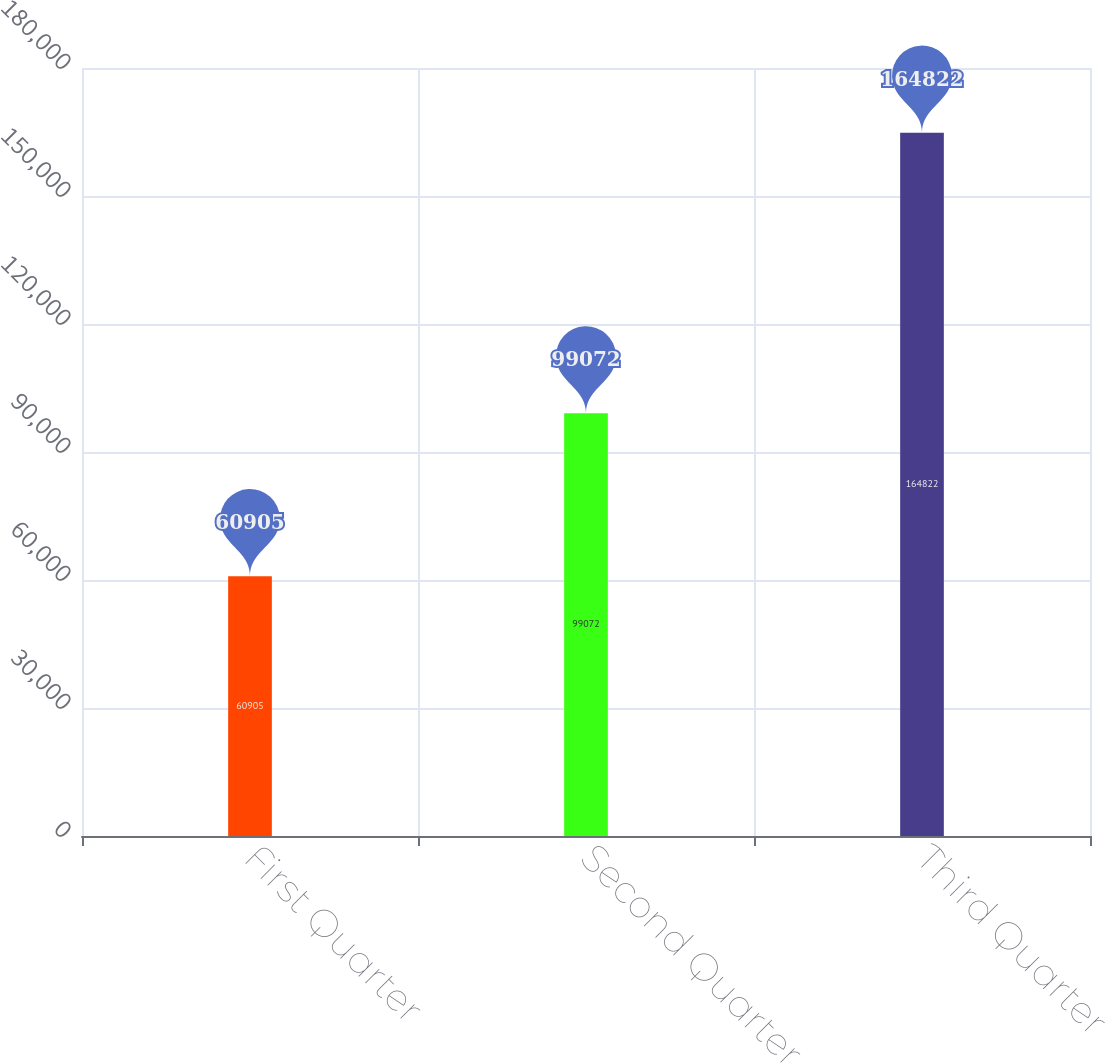Convert chart. <chart><loc_0><loc_0><loc_500><loc_500><bar_chart><fcel>First Quarter<fcel>Second Quarter<fcel>Third Quarter<nl><fcel>60905<fcel>99072<fcel>164822<nl></chart> 